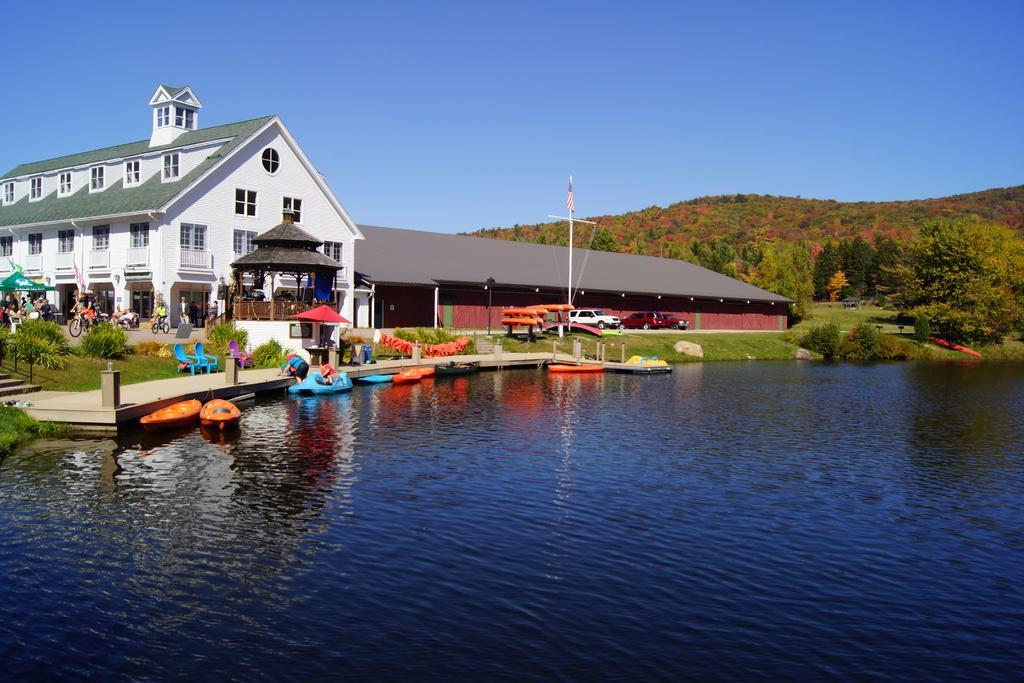Can you describe this image briefly? In this image I can see boats on water. In the background I can see plants, the grass, trees, bicycles, people and poles. I can also see the sky. 